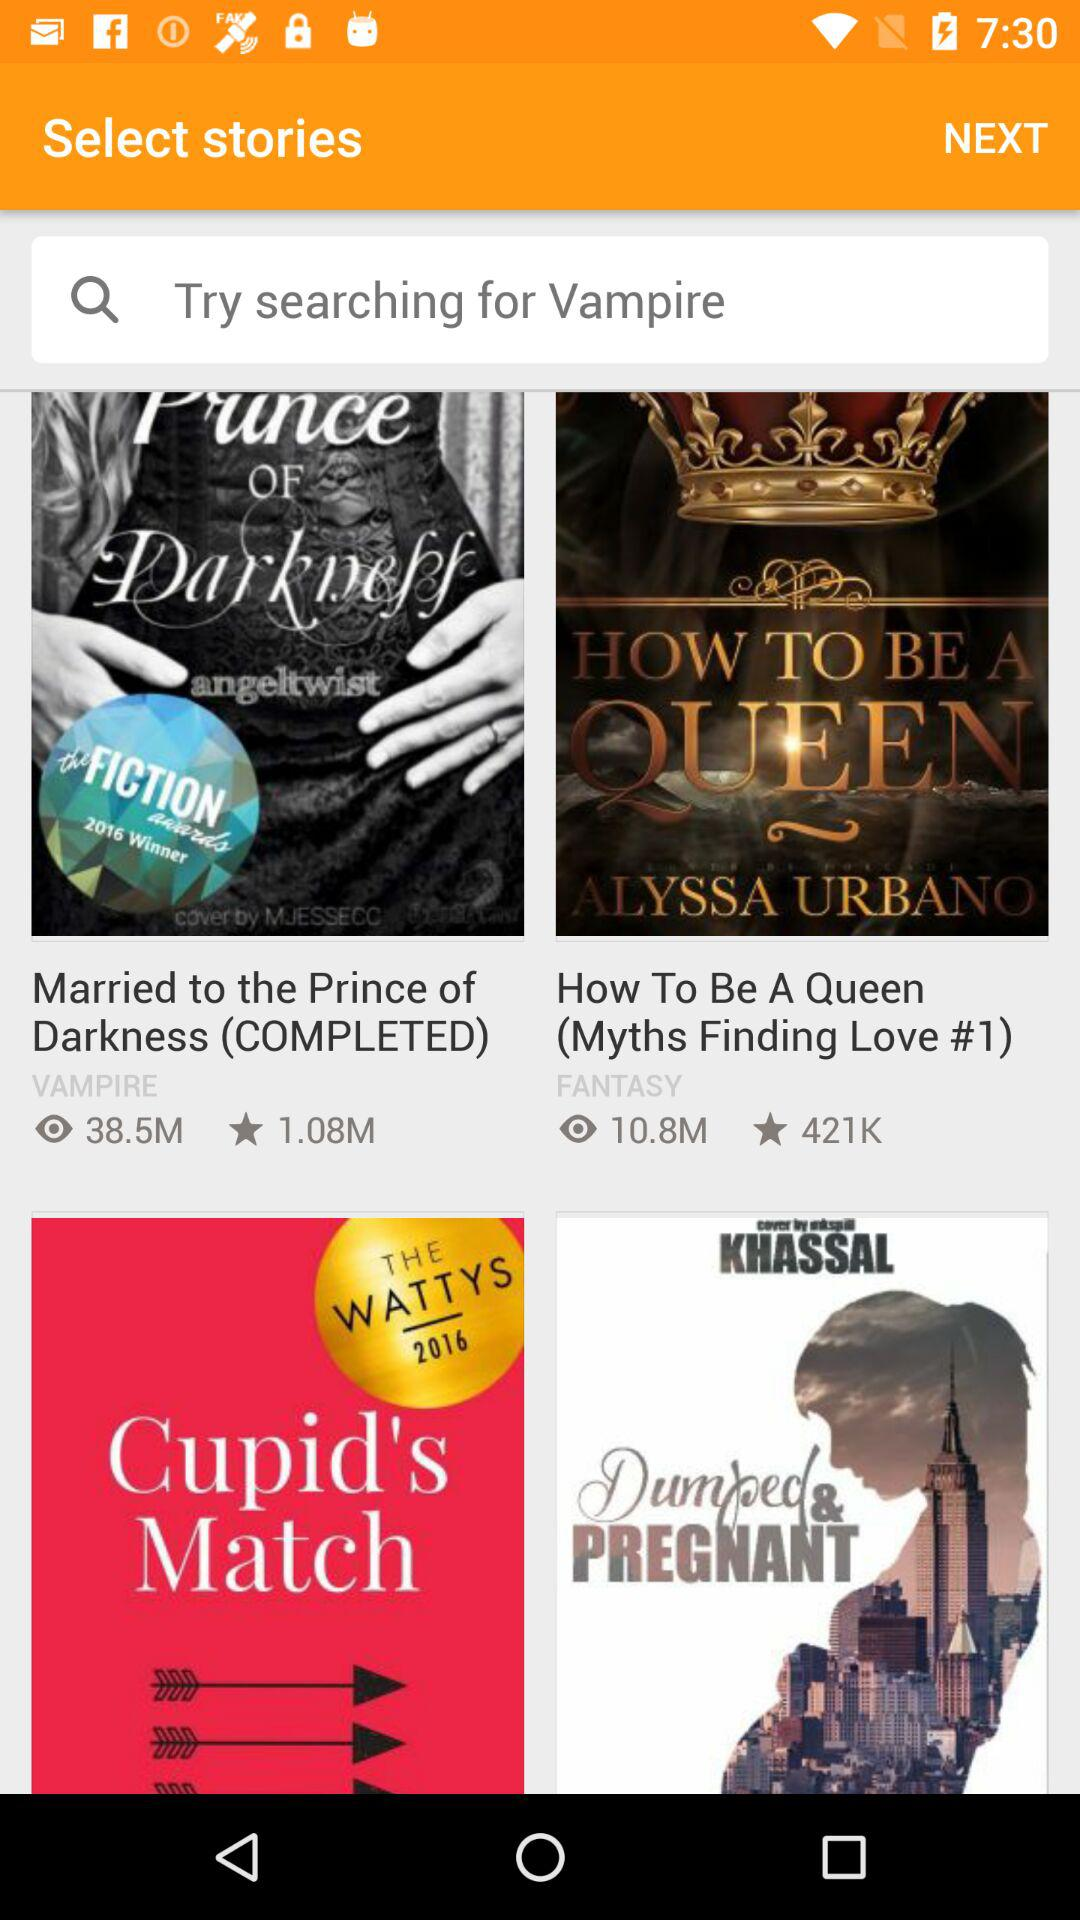How many people voted to be married to the prince of darkness?
When the provided information is insufficient, respond with <no answer>. <no answer> 